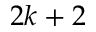<formula> <loc_0><loc_0><loc_500><loc_500>2 k + 2</formula> 